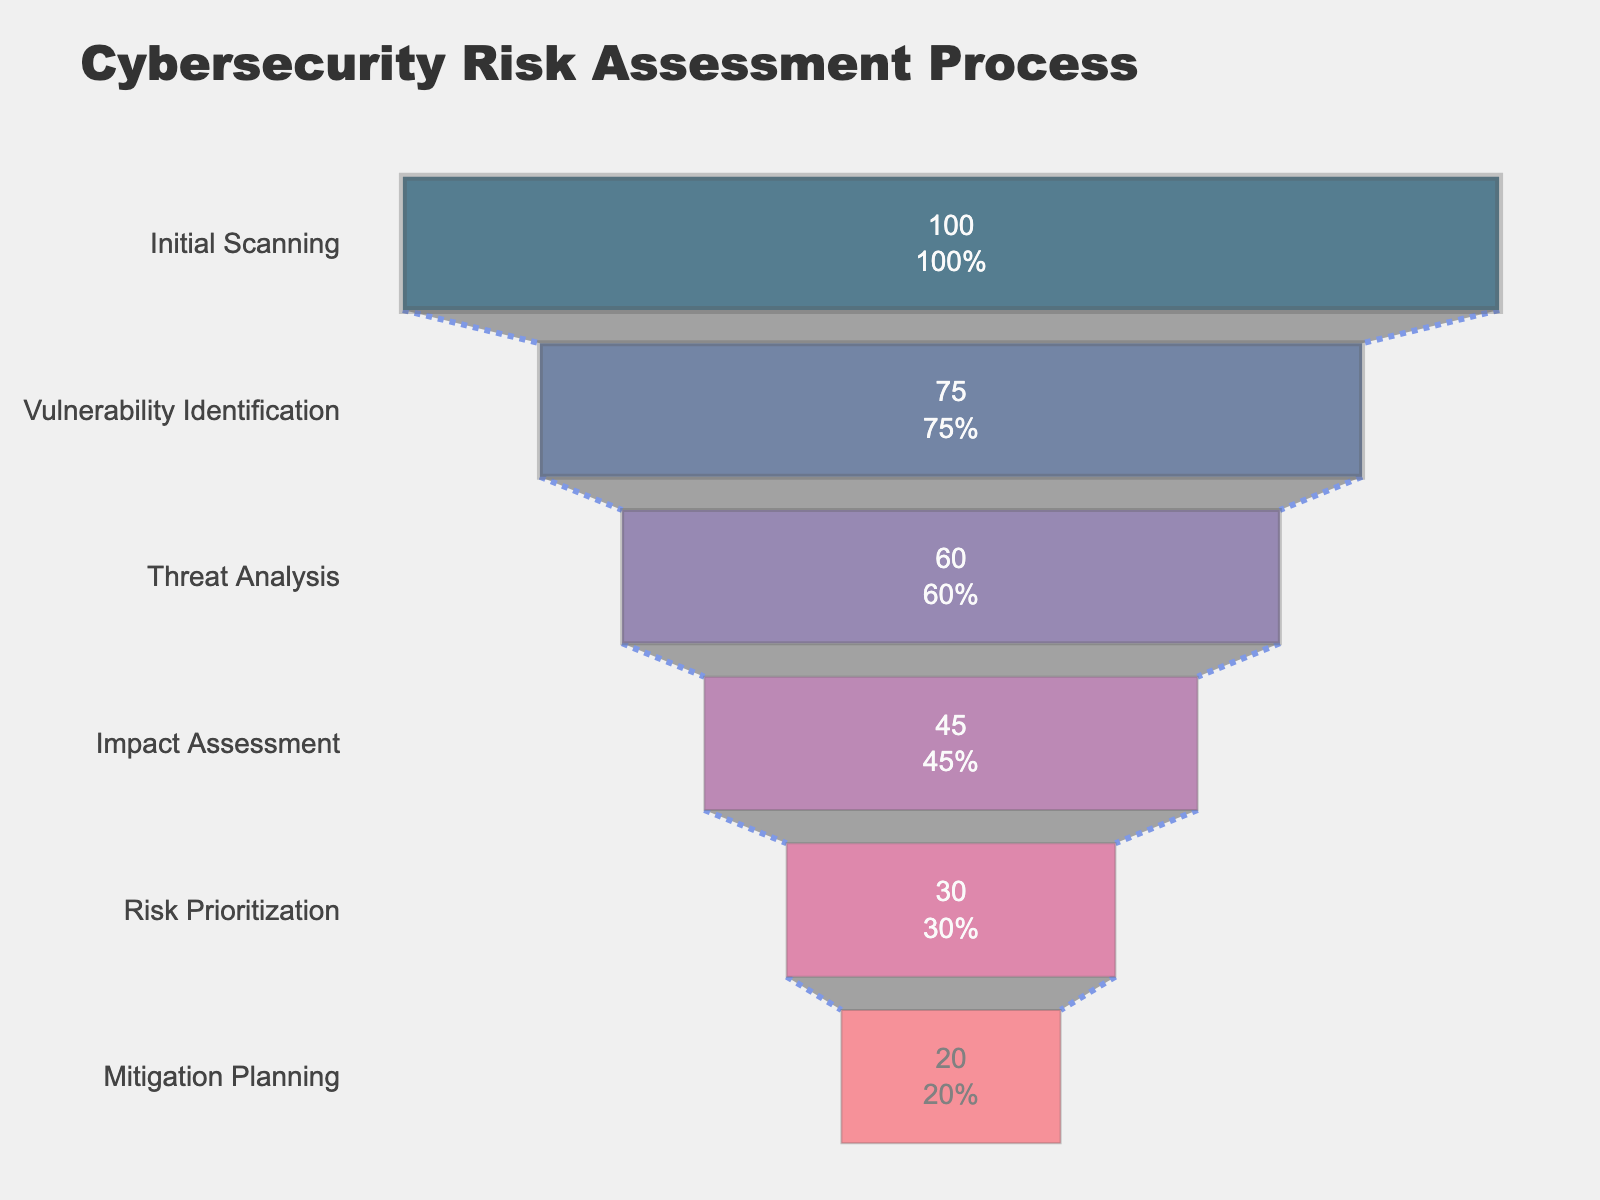How many phases are represented in this funnel chart? To determine the number of phases, we can count the distinct bars or segments representing each phase in the funnel chart.
Answer: 6 What is the title of the chart? The title of the chart is typically displayed at the top of the chart.
Answer: Cybersecurity Risk Assessment Process What percentage of vulnerabilities are identified in the Threat Analysis phase? To find out the percentage for the Threat Analysis phase, refer to the label or height of the corresponding section in the funnel chart.
Answer: 60% Compare the percentage difference between Vulnerability Identification and Impact Assessment phases. The percentage for Vulnerability Identification is 75% while for Impact Assessment it is 45%. The difference between these two percentages is calculated by subtracting 45 from 75.
Answer: 30% What is the final phase in the funnel chart? The final phase in a funnel chart is generally represented at the narrowest end, often being the last segment listed from top to bottom.
Answer: Mitigation Planning Which phase has the highest percentage of identified vulnerabilities? To determine this, we look at the top-most section of the funnel chart, which usually starts with the largest percentage.
Answer: Initial Scanning How much lower is the percentage of identified vulnerabilities in the Risk Prioritization phase compared to the Initial Scanning phase? The initial percentage is 100%, and the percentage for Risk Prioritization is 30%. Subtracting 30 from 100 gives the percentage decrease.
Answer: 70% In terms of percentage points, what is the difference between the Threat Analysis and Mitigation Planning phases? The Threat Analysis phase has 60% and the Mitigation Planning phase has 20%. Subtracting these gives 40 percentage points.
Answer: 40 If the percentage of identified vulnerabilities at the Mitigation Planning phase were to increase by 10%, what would the new percentage be? Starting with the percentage at Mitigation Planning, which is 20%, and adding 10% gives the updated value.
Answer: 30% What phase comes immediately after the Impact Assessment phase in the funnel chart? To find the phase following Impact Assessment, refer to the next subsequent segment in the funnel chart below the Impact Assessment section.
Answer: Risk Prioritization 